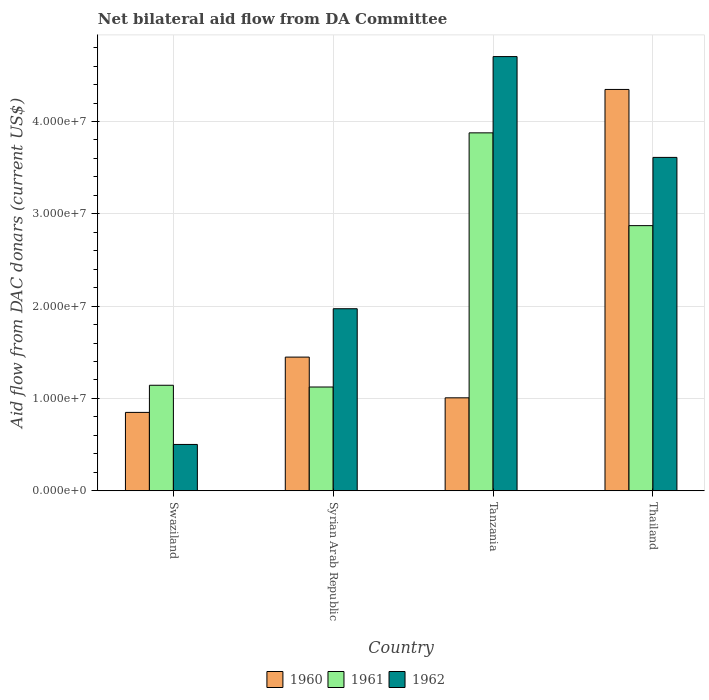How many bars are there on the 1st tick from the left?
Ensure brevity in your answer.  3. How many bars are there on the 1st tick from the right?
Your response must be concise. 3. What is the label of the 3rd group of bars from the left?
Your answer should be compact. Tanzania. What is the aid flow in in 1960 in Swaziland?
Your answer should be compact. 8.49e+06. Across all countries, what is the maximum aid flow in in 1962?
Provide a short and direct response. 4.70e+07. Across all countries, what is the minimum aid flow in in 1960?
Offer a terse response. 8.49e+06. In which country was the aid flow in in 1962 maximum?
Provide a short and direct response. Tanzania. In which country was the aid flow in in 1960 minimum?
Your response must be concise. Swaziland. What is the total aid flow in in 1961 in the graph?
Your answer should be very brief. 9.02e+07. What is the difference between the aid flow in in 1960 in Syrian Arab Republic and that in Tanzania?
Ensure brevity in your answer.  4.41e+06. What is the difference between the aid flow in in 1962 in Syrian Arab Republic and the aid flow in in 1960 in Tanzania?
Provide a succinct answer. 9.65e+06. What is the average aid flow in in 1960 per country?
Offer a very short reply. 1.91e+07. What is the difference between the aid flow in of/in 1960 and aid flow in of/in 1962 in Syrian Arab Republic?
Your answer should be compact. -5.24e+06. What is the ratio of the aid flow in in 1961 in Syrian Arab Republic to that in Thailand?
Offer a very short reply. 0.39. Is the aid flow in in 1962 in Swaziland less than that in Thailand?
Your answer should be compact. Yes. Is the difference between the aid flow in in 1960 in Swaziland and Syrian Arab Republic greater than the difference between the aid flow in in 1962 in Swaziland and Syrian Arab Republic?
Provide a succinct answer. Yes. What is the difference between the highest and the second highest aid flow in in 1961?
Ensure brevity in your answer.  2.73e+07. What is the difference between the highest and the lowest aid flow in in 1961?
Offer a terse response. 2.75e+07. In how many countries, is the aid flow in in 1962 greater than the average aid flow in in 1962 taken over all countries?
Give a very brief answer. 2. Is the sum of the aid flow in in 1961 in Syrian Arab Republic and Thailand greater than the maximum aid flow in in 1962 across all countries?
Your response must be concise. No. What does the 3rd bar from the left in Syrian Arab Republic represents?
Provide a short and direct response. 1962. What does the 2nd bar from the right in Tanzania represents?
Offer a very short reply. 1961. Is it the case that in every country, the sum of the aid flow in in 1962 and aid flow in in 1961 is greater than the aid flow in in 1960?
Provide a succinct answer. Yes. How many bars are there?
Your answer should be compact. 12. Are all the bars in the graph horizontal?
Keep it short and to the point. No. Are the values on the major ticks of Y-axis written in scientific E-notation?
Make the answer very short. Yes. Does the graph contain any zero values?
Your response must be concise. No. Does the graph contain grids?
Your response must be concise. Yes. What is the title of the graph?
Provide a short and direct response. Net bilateral aid flow from DA Committee. Does "1993" appear as one of the legend labels in the graph?
Your answer should be very brief. No. What is the label or title of the X-axis?
Provide a short and direct response. Country. What is the label or title of the Y-axis?
Give a very brief answer. Aid flow from DAC donars (current US$). What is the Aid flow from DAC donars (current US$) in 1960 in Swaziland?
Provide a succinct answer. 8.49e+06. What is the Aid flow from DAC donars (current US$) of 1961 in Swaziland?
Keep it short and to the point. 1.14e+07. What is the Aid flow from DAC donars (current US$) of 1962 in Swaziland?
Your response must be concise. 5.02e+06. What is the Aid flow from DAC donars (current US$) in 1960 in Syrian Arab Republic?
Your answer should be compact. 1.45e+07. What is the Aid flow from DAC donars (current US$) in 1961 in Syrian Arab Republic?
Make the answer very short. 1.12e+07. What is the Aid flow from DAC donars (current US$) in 1962 in Syrian Arab Republic?
Ensure brevity in your answer.  1.97e+07. What is the Aid flow from DAC donars (current US$) of 1960 in Tanzania?
Keep it short and to the point. 1.01e+07. What is the Aid flow from DAC donars (current US$) in 1961 in Tanzania?
Your answer should be compact. 3.88e+07. What is the Aid flow from DAC donars (current US$) of 1962 in Tanzania?
Provide a short and direct response. 4.70e+07. What is the Aid flow from DAC donars (current US$) in 1960 in Thailand?
Ensure brevity in your answer.  4.35e+07. What is the Aid flow from DAC donars (current US$) of 1961 in Thailand?
Offer a very short reply. 2.87e+07. What is the Aid flow from DAC donars (current US$) of 1962 in Thailand?
Ensure brevity in your answer.  3.61e+07. Across all countries, what is the maximum Aid flow from DAC donars (current US$) in 1960?
Make the answer very short. 4.35e+07. Across all countries, what is the maximum Aid flow from DAC donars (current US$) of 1961?
Keep it short and to the point. 3.88e+07. Across all countries, what is the maximum Aid flow from DAC donars (current US$) in 1962?
Offer a terse response. 4.70e+07. Across all countries, what is the minimum Aid flow from DAC donars (current US$) of 1960?
Give a very brief answer. 8.49e+06. Across all countries, what is the minimum Aid flow from DAC donars (current US$) in 1961?
Provide a short and direct response. 1.12e+07. Across all countries, what is the minimum Aid flow from DAC donars (current US$) in 1962?
Offer a terse response. 5.02e+06. What is the total Aid flow from DAC donars (current US$) of 1960 in the graph?
Provide a short and direct response. 7.65e+07. What is the total Aid flow from DAC donars (current US$) in 1961 in the graph?
Provide a short and direct response. 9.02e+07. What is the total Aid flow from DAC donars (current US$) in 1962 in the graph?
Provide a succinct answer. 1.08e+08. What is the difference between the Aid flow from DAC donars (current US$) of 1960 in Swaziland and that in Syrian Arab Republic?
Keep it short and to the point. -5.99e+06. What is the difference between the Aid flow from DAC donars (current US$) in 1962 in Swaziland and that in Syrian Arab Republic?
Offer a very short reply. -1.47e+07. What is the difference between the Aid flow from DAC donars (current US$) in 1960 in Swaziland and that in Tanzania?
Keep it short and to the point. -1.58e+06. What is the difference between the Aid flow from DAC donars (current US$) of 1961 in Swaziland and that in Tanzania?
Make the answer very short. -2.73e+07. What is the difference between the Aid flow from DAC donars (current US$) in 1962 in Swaziland and that in Tanzania?
Keep it short and to the point. -4.20e+07. What is the difference between the Aid flow from DAC donars (current US$) of 1960 in Swaziland and that in Thailand?
Give a very brief answer. -3.50e+07. What is the difference between the Aid flow from DAC donars (current US$) in 1961 in Swaziland and that in Thailand?
Your answer should be very brief. -1.73e+07. What is the difference between the Aid flow from DAC donars (current US$) of 1962 in Swaziland and that in Thailand?
Your answer should be very brief. -3.11e+07. What is the difference between the Aid flow from DAC donars (current US$) in 1960 in Syrian Arab Republic and that in Tanzania?
Your answer should be compact. 4.41e+06. What is the difference between the Aid flow from DAC donars (current US$) of 1961 in Syrian Arab Republic and that in Tanzania?
Your response must be concise. -2.75e+07. What is the difference between the Aid flow from DAC donars (current US$) of 1962 in Syrian Arab Republic and that in Tanzania?
Provide a succinct answer. -2.73e+07. What is the difference between the Aid flow from DAC donars (current US$) in 1960 in Syrian Arab Republic and that in Thailand?
Provide a short and direct response. -2.90e+07. What is the difference between the Aid flow from DAC donars (current US$) of 1961 in Syrian Arab Republic and that in Thailand?
Your response must be concise. -1.75e+07. What is the difference between the Aid flow from DAC donars (current US$) in 1962 in Syrian Arab Republic and that in Thailand?
Your response must be concise. -1.64e+07. What is the difference between the Aid flow from DAC donars (current US$) of 1960 in Tanzania and that in Thailand?
Make the answer very short. -3.34e+07. What is the difference between the Aid flow from DAC donars (current US$) in 1961 in Tanzania and that in Thailand?
Offer a very short reply. 1.00e+07. What is the difference between the Aid flow from DAC donars (current US$) of 1962 in Tanzania and that in Thailand?
Offer a terse response. 1.09e+07. What is the difference between the Aid flow from DAC donars (current US$) in 1960 in Swaziland and the Aid flow from DAC donars (current US$) in 1961 in Syrian Arab Republic?
Make the answer very short. -2.75e+06. What is the difference between the Aid flow from DAC donars (current US$) of 1960 in Swaziland and the Aid flow from DAC donars (current US$) of 1962 in Syrian Arab Republic?
Offer a very short reply. -1.12e+07. What is the difference between the Aid flow from DAC donars (current US$) in 1961 in Swaziland and the Aid flow from DAC donars (current US$) in 1962 in Syrian Arab Republic?
Provide a short and direct response. -8.29e+06. What is the difference between the Aid flow from DAC donars (current US$) of 1960 in Swaziland and the Aid flow from DAC donars (current US$) of 1961 in Tanzania?
Give a very brief answer. -3.03e+07. What is the difference between the Aid flow from DAC donars (current US$) of 1960 in Swaziland and the Aid flow from DAC donars (current US$) of 1962 in Tanzania?
Offer a very short reply. -3.85e+07. What is the difference between the Aid flow from DAC donars (current US$) of 1961 in Swaziland and the Aid flow from DAC donars (current US$) of 1962 in Tanzania?
Provide a succinct answer. -3.56e+07. What is the difference between the Aid flow from DAC donars (current US$) of 1960 in Swaziland and the Aid flow from DAC donars (current US$) of 1961 in Thailand?
Ensure brevity in your answer.  -2.02e+07. What is the difference between the Aid flow from DAC donars (current US$) in 1960 in Swaziland and the Aid flow from DAC donars (current US$) in 1962 in Thailand?
Offer a very short reply. -2.76e+07. What is the difference between the Aid flow from DAC donars (current US$) of 1961 in Swaziland and the Aid flow from DAC donars (current US$) of 1962 in Thailand?
Your response must be concise. -2.47e+07. What is the difference between the Aid flow from DAC donars (current US$) in 1960 in Syrian Arab Republic and the Aid flow from DAC donars (current US$) in 1961 in Tanzania?
Make the answer very short. -2.43e+07. What is the difference between the Aid flow from DAC donars (current US$) in 1960 in Syrian Arab Republic and the Aid flow from DAC donars (current US$) in 1962 in Tanzania?
Ensure brevity in your answer.  -3.26e+07. What is the difference between the Aid flow from DAC donars (current US$) in 1961 in Syrian Arab Republic and the Aid flow from DAC donars (current US$) in 1962 in Tanzania?
Make the answer very short. -3.58e+07. What is the difference between the Aid flow from DAC donars (current US$) of 1960 in Syrian Arab Republic and the Aid flow from DAC donars (current US$) of 1961 in Thailand?
Your answer should be compact. -1.42e+07. What is the difference between the Aid flow from DAC donars (current US$) in 1960 in Syrian Arab Republic and the Aid flow from DAC donars (current US$) in 1962 in Thailand?
Provide a succinct answer. -2.16e+07. What is the difference between the Aid flow from DAC donars (current US$) of 1961 in Syrian Arab Republic and the Aid flow from DAC donars (current US$) of 1962 in Thailand?
Give a very brief answer. -2.49e+07. What is the difference between the Aid flow from DAC donars (current US$) of 1960 in Tanzania and the Aid flow from DAC donars (current US$) of 1961 in Thailand?
Provide a succinct answer. -1.86e+07. What is the difference between the Aid flow from DAC donars (current US$) of 1960 in Tanzania and the Aid flow from DAC donars (current US$) of 1962 in Thailand?
Your answer should be very brief. -2.60e+07. What is the difference between the Aid flow from DAC donars (current US$) of 1961 in Tanzania and the Aid flow from DAC donars (current US$) of 1962 in Thailand?
Provide a short and direct response. 2.66e+06. What is the average Aid flow from DAC donars (current US$) of 1960 per country?
Offer a terse response. 1.91e+07. What is the average Aid flow from DAC donars (current US$) of 1961 per country?
Your response must be concise. 2.25e+07. What is the average Aid flow from DAC donars (current US$) in 1962 per country?
Offer a very short reply. 2.70e+07. What is the difference between the Aid flow from DAC donars (current US$) of 1960 and Aid flow from DAC donars (current US$) of 1961 in Swaziland?
Make the answer very short. -2.94e+06. What is the difference between the Aid flow from DAC donars (current US$) of 1960 and Aid flow from DAC donars (current US$) of 1962 in Swaziland?
Your answer should be compact. 3.47e+06. What is the difference between the Aid flow from DAC donars (current US$) in 1961 and Aid flow from DAC donars (current US$) in 1962 in Swaziland?
Provide a succinct answer. 6.41e+06. What is the difference between the Aid flow from DAC donars (current US$) of 1960 and Aid flow from DAC donars (current US$) of 1961 in Syrian Arab Republic?
Your response must be concise. 3.24e+06. What is the difference between the Aid flow from DAC donars (current US$) in 1960 and Aid flow from DAC donars (current US$) in 1962 in Syrian Arab Republic?
Your response must be concise. -5.24e+06. What is the difference between the Aid flow from DAC donars (current US$) of 1961 and Aid flow from DAC donars (current US$) of 1962 in Syrian Arab Republic?
Give a very brief answer. -8.48e+06. What is the difference between the Aid flow from DAC donars (current US$) in 1960 and Aid flow from DAC donars (current US$) in 1961 in Tanzania?
Provide a succinct answer. -2.87e+07. What is the difference between the Aid flow from DAC donars (current US$) of 1960 and Aid flow from DAC donars (current US$) of 1962 in Tanzania?
Give a very brief answer. -3.70e+07. What is the difference between the Aid flow from DAC donars (current US$) of 1961 and Aid flow from DAC donars (current US$) of 1962 in Tanzania?
Make the answer very short. -8.26e+06. What is the difference between the Aid flow from DAC donars (current US$) of 1960 and Aid flow from DAC donars (current US$) of 1961 in Thailand?
Offer a very short reply. 1.48e+07. What is the difference between the Aid flow from DAC donars (current US$) of 1960 and Aid flow from DAC donars (current US$) of 1962 in Thailand?
Your answer should be very brief. 7.36e+06. What is the difference between the Aid flow from DAC donars (current US$) of 1961 and Aid flow from DAC donars (current US$) of 1962 in Thailand?
Provide a succinct answer. -7.39e+06. What is the ratio of the Aid flow from DAC donars (current US$) of 1960 in Swaziland to that in Syrian Arab Republic?
Your response must be concise. 0.59. What is the ratio of the Aid flow from DAC donars (current US$) in 1961 in Swaziland to that in Syrian Arab Republic?
Keep it short and to the point. 1.02. What is the ratio of the Aid flow from DAC donars (current US$) in 1962 in Swaziland to that in Syrian Arab Republic?
Your answer should be compact. 0.25. What is the ratio of the Aid flow from DAC donars (current US$) in 1960 in Swaziland to that in Tanzania?
Your answer should be compact. 0.84. What is the ratio of the Aid flow from DAC donars (current US$) of 1961 in Swaziland to that in Tanzania?
Offer a terse response. 0.29. What is the ratio of the Aid flow from DAC donars (current US$) of 1962 in Swaziland to that in Tanzania?
Provide a succinct answer. 0.11. What is the ratio of the Aid flow from DAC donars (current US$) in 1960 in Swaziland to that in Thailand?
Your answer should be compact. 0.2. What is the ratio of the Aid flow from DAC donars (current US$) in 1961 in Swaziland to that in Thailand?
Your response must be concise. 0.4. What is the ratio of the Aid flow from DAC donars (current US$) of 1962 in Swaziland to that in Thailand?
Your answer should be very brief. 0.14. What is the ratio of the Aid flow from DAC donars (current US$) of 1960 in Syrian Arab Republic to that in Tanzania?
Keep it short and to the point. 1.44. What is the ratio of the Aid flow from DAC donars (current US$) of 1961 in Syrian Arab Republic to that in Tanzania?
Your answer should be compact. 0.29. What is the ratio of the Aid flow from DAC donars (current US$) of 1962 in Syrian Arab Republic to that in Tanzania?
Offer a very short reply. 0.42. What is the ratio of the Aid flow from DAC donars (current US$) in 1960 in Syrian Arab Republic to that in Thailand?
Your answer should be very brief. 0.33. What is the ratio of the Aid flow from DAC donars (current US$) of 1961 in Syrian Arab Republic to that in Thailand?
Provide a succinct answer. 0.39. What is the ratio of the Aid flow from DAC donars (current US$) of 1962 in Syrian Arab Republic to that in Thailand?
Your response must be concise. 0.55. What is the ratio of the Aid flow from DAC donars (current US$) of 1960 in Tanzania to that in Thailand?
Provide a succinct answer. 0.23. What is the ratio of the Aid flow from DAC donars (current US$) of 1961 in Tanzania to that in Thailand?
Your response must be concise. 1.35. What is the ratio of the Aid flow from DAC donars (current US$) in 1962 in Tanzania to that in Thailand?
Your answer should be very brief. 1.3. What is the difference between the highest and the second highest Aid flow from DAC donars (current US$) of 1960?
Keep it short and to the point. 2.90e+07. What is the difference between the highest and the second highest Aid flow from DAC donars (current US$) of 1961?
Provide a succinct answer. 1.00e+07. What is the difference between the highest and the second highest Aid flow from DAC donars (current US$) of 1962?
Your response must be concise. 1.09e+07. What is the difference between the highest and the lowest Aid flow from DAC donars (current US$) of 1960?
Ensure brevity in your answer.  3.50e+07. What is the difference between the highest and the lowest Aid flow from DAC donars (current US$) of 1961?
Provide a succinct answer. 2.75e+07. What is the difference between the highest and the lowest Aid flow from DAC donars (current US$) of 1962?
Make the answer very short. 4.20e+07. 